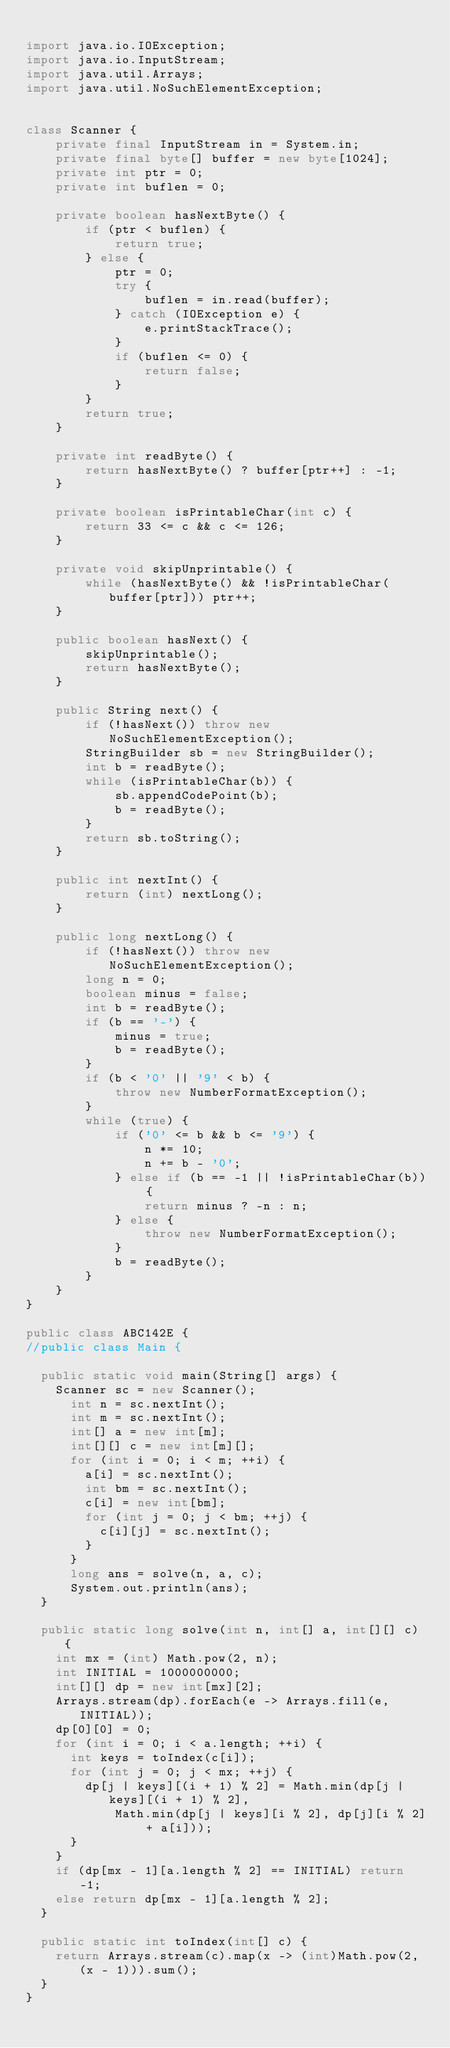<code> <loc_0><loc_0><loc_500><loc_500><_Java_>
import java.io.IOException;
import java.io.InputStream;
import java.util.Arrays;
import java.util.NoSuchElementException;


class Scanner {
    private final InputStream in = System.in;
    private final byte[] buffer = new byte[1024];
    private int ptr = 0;
    private int buflen = 0;

    private boolean hasNextByte() {
        if (ptr < buflen) {
            return true;
        } else {
            ptr = 0;
            try {
                buflen = in.read(buffer);
            } catch (IOException e) {
                e.printStackTrace();
            }
            if (buflen <= 0) {
                return false;
            }
        }
        return true;
    }

    private int readByte() {
        return hasNextByte() ? buffer[ptr++] : -1;
    }

    private boolean isPrintableChar(int c) {
        return 33 <= c && c <= 126;
    }

    private void skipUnprintable() {
        while (hasNextByte() && !isPrintableChar(buffer[ptr])) ptr++;
    }

    public boolean hasNext() {
        skipUnprintable();
        return hasNextByte();
    }

    public String next() {
        if (!hasNext()) throw new NoSuchElementException();
        StringBuilder sb = new StringBuilder();
        int b = readByte();
        while (isPrintableChar(b)) {
            sb.appendCodePoint(b);
            b = readByte();
        }
        return sb.toString();
    }

    public int nextInt() {
        return (int) nextLong();
    }

    public long nextLong() {
        if (!hasNext()) throw new NoSuchElementException();
        long n = 0;
        boolean minus = false;
        int b = readByte();
        if (b == '-') {
            minus = true;
            b = readByte();
        }
        if (b < '0' || '9' < b) {
            throw new NumberFormatException();
        }
        while (true) {
            if ('0' <= b && b <= '9') {
                n *= 10;
                n += b - '0';
            } else if (b == -1 || !isPrintableChar(b)) {
                return minus ? -n : n;
            } else {
                throw new NumberFormatException();
            }
            b = readByte();
        }
    }
}

public class ABC142E {
//public class Main {

	public static void main(String[] args) {
		Scanner sc = new Scanner();
	    int n = sc.nextInt();
	    int m = sc.nextInt();
	    int[] a = new int[m];
	    int[][] c = new int[m][];
	    for (int i = 0; i < m; ++i) {
	    	a[i] = sc.nextInt();
	    	int bm = sc.nextInt();
	    	c[i] = new int[bm];
	    	for (int j = 0; j < bm; ++j) {
	    		c[i][j] = sc.nextInt();
	    	}
	    }
	    long ans = solve(n, a, c);
	    System.out.println(ans);
	}

	public static long solve(int n, int[] a, int[][] c) {
		int mx = (int) Math.pow(2, n);
		int INITIAL = 1000000000;
		int[][] dp = new int[mx][2];
		Arrays.stream(dp).forEach(e -> Arrays.fill(e, INITIAL));
		dp[0][0] = 0;
		for (int i = 0; i < a.length; ++i) {
			int keys = toIndex(c[i]);
			for (int j = 0; j < mx; ++j) {
				dp[j | keys][(i + 1) % 2] = Math.min(dp[j | keys][(i + 1) % 2],
						Math.min(dp[j | keys][i % 2], dp[j][i % 2] + a[i]));
			}
		}
		if (dp[mx - 1][a.length % 2] == INITIAL) return -1;
		else return dp[mx - 1][a.length % 2];
	}

	public static int toIndex(int[] c) {
		return Arrays.stream(c).map(x -> (int)Math.pow(2, (x - 1))).sum();
	}
}
</code> 